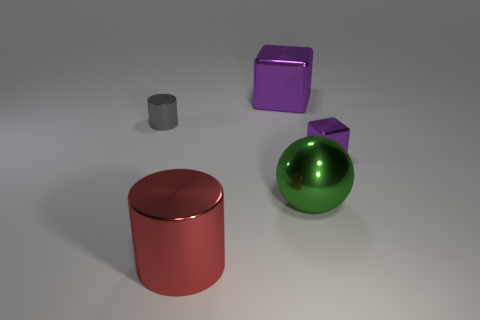There is a big metal cylinder; what number of large cubes are right of it?
Your answer should be compact. 1. What is the color of the small cube that is the same material as the large green sphere?
Give a very brief answer. Purple. There is a gray shiny thing; is its size the same as the metal cylinder in front of the small shiny cylinder?
Ensure brevity in your answer.  No. There is a cube to the left of the small object that is right of the large object in front of the big green thing; how big is it?
Offer a terse response. Large. What number of rubber things are either big green objects or big red cylinders?
Ensure brevity in your answer.  0. There is a cube to the right of the shiny ball; what color is it?
Keep it short and to the point. Purple. There is a purple metallic object that is the same size as the gray object; what shape is it?
Give a very brief answer. Cube. Do the metallic ball and the metallic thing that is on the left side of the red metal object have the same color?
Keep it short and to the point. No. How many objects are either things on the right side of the large red thing or shiny objects in front of the big green shiny sphere?
Your response must be concise. 4. There is a purple object that is the same size as the gray metallic object; what is its material?
Provide a short and direct response. Metal. 